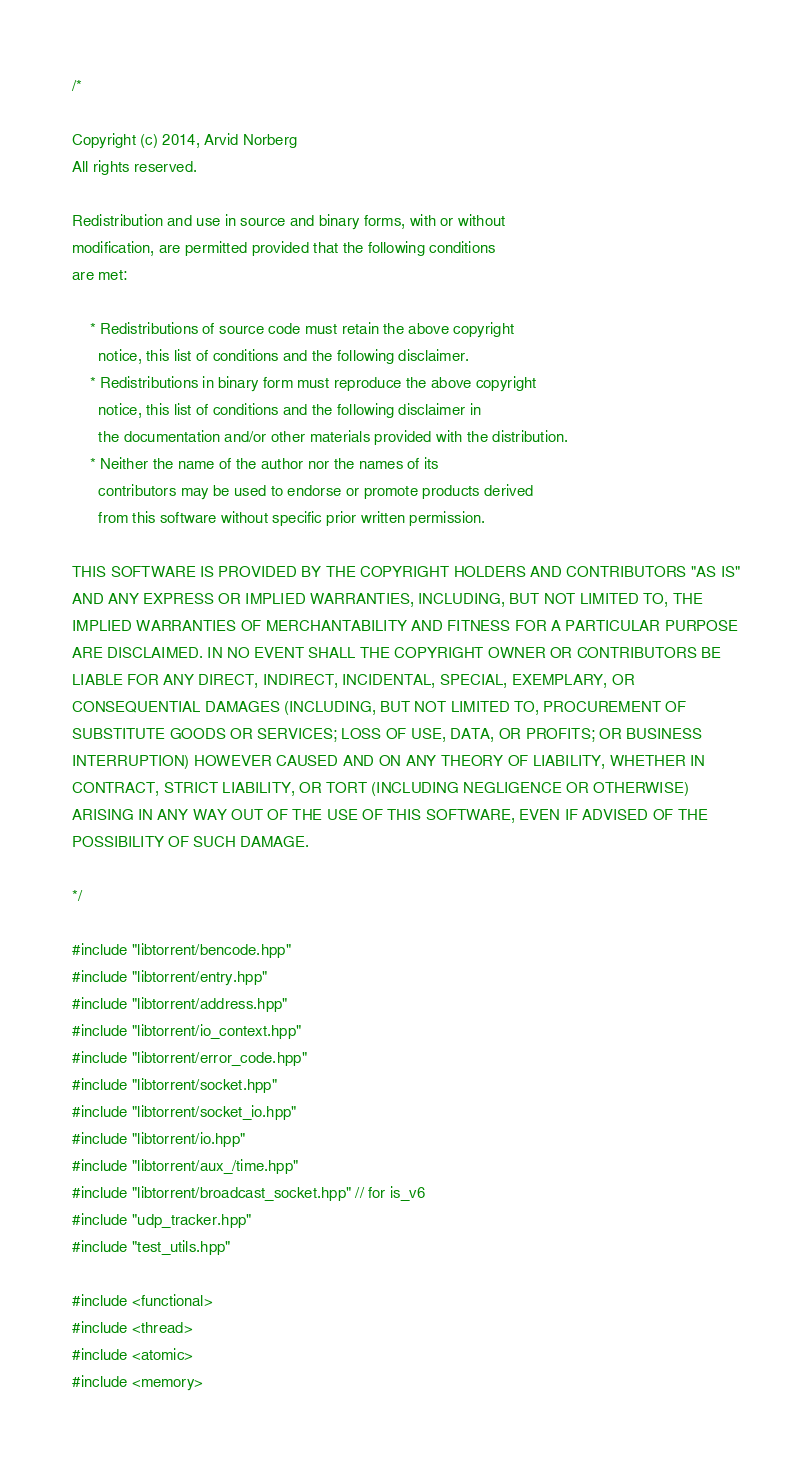<code> <loc_0><loc_0><loc_500><loc_500><_C++_>/*

Copyright (c) 2014, Arvid Norberg
All rights reserved.

Redistribution and use in source and binary forms, with or without
modification, are permitted provided that the following conditions
are met:

    * Redistributions of source code must retain the above copyright
      notice, this list of conditions and the following disclaimer.
    * Redistributions in binary form must reproduce the above copyright
      notice, this list of conditions and the following disclaimer in
      the documentation and/or other materials provided with the distribution.
    * Neither the name of the author nor the names of its
      contributors may be used to endorse or promote products derived
      from this software without specific prior written permission.

THIS SOFTWARE IS PROVIDED BY THE COPYRIGHT HOLDERS AND CONTRIBUTORS "AS IS"
AND ANY EXPRESS OR IMPLIED WARRANTIES, INCLUDING, BUT NOT LIMITED TO, THE
IMPLIED WARRANTIES OF MERCHANTABILITY AND FITNESS FOR A PARTICULAR PURPOSE
ARE DISCLAIMED. IN NO EVENT SHALL THE COPYRIGHT OWNER OR CONTRIBUTORS BE
LIABLE FOR ANY DIRECT, INDIRECT, INCIDENTAL, SPECIAL, EXEMPLARY, OR
CONSEQUENTIAL DAMAGES (INCLUDING, BUT NOT LIMITED TO, PROCUREMENT OF
SUBSTITUTE GOODS OR SERVICES; LOSS OF USE, DATA, OR PROFITS; OR BUSINESS
INTERRUPTION) HOWEVER CAUSED AND ON ANY THEORY OF LIABILITY, WHETHER IN
CONTRACT, STRICT LIABILITY, OR TORT (INCLUDING NEGLIGENCE OR OTHERWISE)
ARISING IN ANY WAY OUT OF THE USE OF THIS SOFTWARE, EVEN IF ADVISED OF THE
POSSIBILITY OF SUCH DAMAGE.

*/

#include "libtorrent/bencode.hpp"
#include "libtorrent/entry.hpp"
#include "libtorrent/address.hpp"
#include "libtorrent/io_context.hpp"
#include "libtorrent/error_code.hpp"
#include "libtorrent/socket.hpp"
#include "libtorrent/socket_io.hpp"
#include "libtorrent/io.hpp"
#include "libtorrent/aux_/time.hpp"
#include "libtorrent/broadcast_socket.hpp" // for is_v6
#include "udp_tracker.hpp"
#include "test_utils.hpp"

#include <functional>
#include <thread>
#include <atomic>
#include <memory>
</code> 